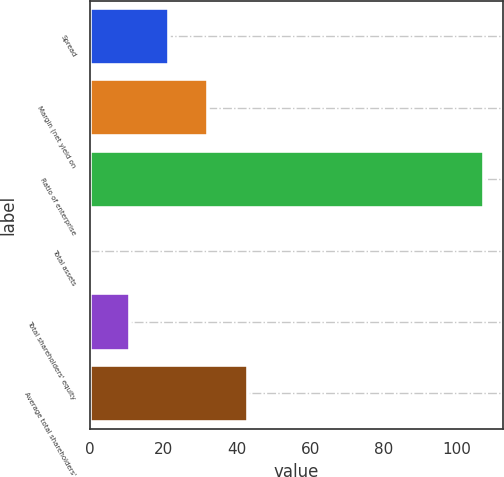<chart> <loc_0><loc_0><loc_500><loc_500><bar_chart><fcel>Spread<fcel>Margin (net yield on<fcel>Ratio of enterprise<fcel>Total assets<fcel>Total shareholders' equity<fcel>Average total shareholders'<nl><fcel>21.59<fcel>32.29<fcel>107.18<fcel>0.19<fcel>10.89<fcel>42.99<nl></chart> 